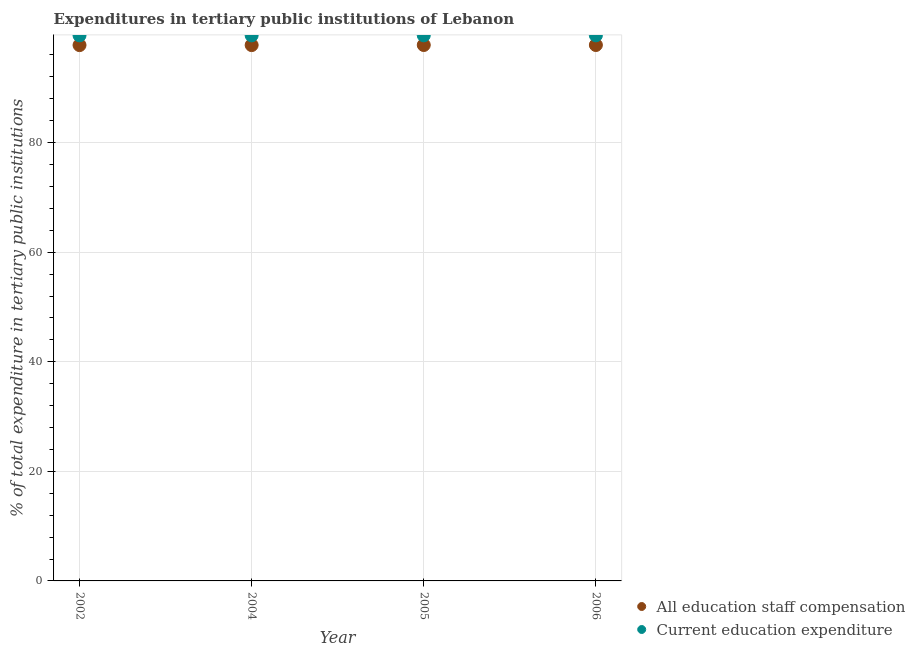Is the number of dotlines equal to the number of legend labels?
Provide a succinct answer. Yes. What is the expenditure in education in 2002?
Keep it short and to the point. 99.57. Across all years, what is the maximum expenditure in education?
Your response must be concise. 99.58. Across all years, what is the minimum expenditure in staff compensation?
Your response must be concise. 97.8. In which year was the expenditure in staff compensation minimum?
Ensure brevity in your answer.  2002. What is the total expenditure in staff compensation in the graph?
Provide a succinct answer. 391.22. What is the difference between the expenditure in staff compensation in 2002 and that in 2005?
Give a very brief answer. -0.02. What is the difference between the expenditure in education in 2002 and the expenditure in staff compensation in 2004?
Your answer should be compact. 1.78. What is the average expenditure in staff compensation per year?
Keep it short and to the point. 97.81. In the year 2006, what is the difference between the expenditure in education and expenditure in staff compensation?
Offer a terse response. 1.76. In how many years, is the expenditure in staff compensation greater than 64 %?
Give a very brief answer. 4. What is the ratio of the expenditure in staff compensation in 2004 to that in 2006?
Your answer should be very brief. 1. Is the expenditure in staff compensation in 2002 less than that in 2006?
Provide a short and direct response. Yes. Is the difference between the expenditure in staff compensation in 2002 and 2004 greater than the difference between the expenditure in education in 2002 and 2004?
Make the answer very short. Yes. What is the difference between the highest and the lowest expenditure in education?
Give a very brief answer. 0. Does the expenditure in education monotonically increase over the years?
Provide a short and direct response. No. How many dotlines are there?
Provide a succinct answer. 2. What is the difference between two consecutive major ticks on the Y-axis?
Provide a short and direct response. 20. How many legend labels are there?
Offer a terse response. 2. What is the title of the graph?
Make the answer very short. Expenditures in tertiary public institutions of Lebanon. Does "IMF concessional" appear as one of the legend labels in the graph?
Provide a short and direct response. No. What is the label or title of the Y-axis?
Offer a terse response. % of total expenditure in tertiary public institutions. What is the % of total expenditure in tertiary public institutions of All education staff compensation in 2002?
Give a very brief answer. 97.8. What is the % of total expenditure in tertiary public institutions of Current education expenditure in 2002?
Make the answer very short. 99.57. What is the % of total expenditure in tertiary public institutions in All education staff compensation in 2004?
Give a very brief answer. 97.8. What is the % of total expenditure in tertiary public institutions of Current education expenditure in 2004?
Keep it short and to the point. 99.57. What is the % of total expenditure in tertiary public institutions of All education staff compensation in 2005?
Give a very brief answer. 97.81. What is the % of total expenditure in tertiary public institutions in Current education expenditure in 2005?
Ensure brevity in your answer.  99.58. What is the % of total expenditure in tertiary public institutions of All education staff compensation in 2006?
Keep it short and to the point. 97.81. What is the % of total expenditure in tertiary public institutions in Current education expenditure in 2006?
Offer a terse response. 99.58. Across all years, what is the maximum % of total expenditure in tertiary public institutions of All education staff compensation?
Provide a succinct answer. 97.81. Across all years, what is the maximum % of total expenditure in tertiary public institutions in Current education expenditure?
Provide a short and direct response. 99.58. Across all years, what is the minimum % of total expenditure in tertiary public institutions of All education staff compensation?
Make the answer very short. 97.8. Across all years, what is the minimum % of total expenditure in tertiary public institutions of Current education expenditure?
Offer a very short reply. 99.57. What is the total % of total expenditure in tertiary public institutions in All education staff compensation in the graph?
Provide a short and direct response. 391.22. What is the total % of total expenditure in tertiary public institutions of Current education expenditure in the graph?
Keep it short and to the point. 398.3. What is the difference between the % of total expenditure in tertiary public institutions in All education staff compensation in 2002 and that in 2004?
Your response must be concise. -0. What is the difference between the % of total expenditure in tertiary public institutions of Current education expenditure in 2002 and that in 2004?
Make the answer very short. -0. What is the difference between the % of total expenditure in tertiary public institutions in All education staff compensation in 2002 and that in 2005?
Make the answer very short. -0.02. What is the difference between the % of total expenditure in tertiary public institutions of Current education expenditure in 2002 and that in 2005?
Your answer should be very brief. -0. What is the difference between the % of total expenditure in tertiary public institutions in All education staff compensation in 2002 and that in 2006?
Give a very brief answer. -0.02. What is the difference between the % of total expenditure in tertiary public institutions of Current education expenditure in 2002 and that in 2006?
Ensure brevity in your answer.  -0. What is the difference between the % of total expenditure in tertiary public institutions in All education staff compensation in 2004 and that in 2005?
Offer a terse response. -0.02. What is the difference between the % of total expenditure in tertiary public institutions in Current education expenditure in 2004 and that in 2005?
Make the answer very short. -0. What is the difference between the % of total expenditure in tertiary public institutions in All education staff compensation in 2004 and that in 2006?
Offer a very short reply. -0.02. What is the difference between the % of total expenditure in tertiary public institutions in Current education expenditure in 2004 and that in 2006?
Offer a terse response. -0. What is the difference between the % of total expenditure in tertiary public institutions in All education staff compensation in 2005 and that in 2006?
Your answer should be compact. 0. What is the difference between the % of total expenditure in tertiary public institutions in All education staff compensation in 2002 and the % of total expenditure in tertiary public institutions in Current education expenditure in 2004?
Keep it short and to the point. -1.78. What is the difference between the % of total expenditure in tertiary public institutions of All education staff compensation in 2002 and the % of total expenditure in tertiary public institutions of Current education expenditure in 2005?
Make the answer very short. -1.78. What is the difference between the % of total expenditure in tertiary public institutions in All education staff compensation in 2002 and the % of total expenditure in tertiary public institutions in Current education expenditure in 2006?
Offer a terse response. -1.78. What is the difference between the % of total expenditure in tertiary public institutions of All education staff compensation in 2004 and the % of total expenditure in tertiary public institutions of Current education expenditure in 2005?
Offer a terse response. -1.78. What is the difference between the % of total expenditure in tertiary public institutions of All education staff compensation in 2004 and the % of total expenditure in tertiary public institutions of Current education expenditure in 2006?
Your response must be concise. -1.78. What is the difference between the % of total expenditure in tertiary public institutions of All education staff compensation in 2005 and the % of total expenditure in tertiary public institutions of Current education expenditure in 2006?
Make the answer very short. -1.76. What is the average % of total expenditure in tertiary public institutions of All education staff compensation per year?
Give a very brief answer. 97.81. What is the average % of total expenditure in tertiary public institutions in Current education expenditure per year?
Give a very brief answer. 99.57. In the year 2002, what is the difference between the % of total expenditure in tertiary public institutions in All education staff compensation and % of total expenditure in tertiary public institutions in Current education expenditure?
Your answer should be very brief. -1.78. In the year 2004, what is the difference between the % of total expenditure in tertiary public institutions in All education staff compensation and % of total expenditure in tertiary public institutions in Current education expenditure?
Keep it short and to the point. -1.78. In the year 2005, what is the difference between the % of total expenditure in tertiary public institutions of All education staff compensation and % of total expenditure in tertiary public institutions of Current education expenditure?
Offer a terse response. -1.76. In the year 2006, what is the difference between the % of total expenditure in tertiary public institutions of All education staff compensation and % of total expenditure in tertiary public institutions of Current education expenditure?
Offer a very short reply. -1.76. What is the ratio of the % of total expenditure in tertiary public institutions in All education staff compensation in 2002 to that in 2004?
Your answer should be compact. 1. What is the ratio of the % of total expenditure in tertiary public institutions in Current education expenditure in 2002 to that in 2004?
Offer a very short reply. 1. What is the ratio of the % of total expenditure in tertiary public institutions in All education staff compensation in 2002 to that in 2005?
Offer a terse response. 1. What is the ratio of the % of total expenditure in tertiary public institutions of Current education expenditure in 2002 to that in 2005?
Your answer should be very brief. 1. What is the ratio of the % of total expenditure in tertiary public institutions of Current education expenditure in 2002 to that in 2006?
Make the answer very short. 1. What is the ratio of the % of total expenditure in tertiary public institutions of Current education expenditure in 2004 to that in 2005?
Give a very brief answer. 1. What is the ratio of the % of total expenditure in tertiary public institutions of All education staff compensation in 2005 to that in 2006?
Make the answer very short. 1. What is the difference between the highest and the second highest % of total expenditure in tertiary public institutions of All education staff compensation?
Provide a succinct answer. 0. What is the difference between the highest and the lowest % of total expenditure in tertiary public institutions in All education staff compensation?
Your answer should be very brief. 0.02. What is the difference between the highest and the lowest % of total expenditure in tertiary public institutions in Current education expenditure?
Provide a short and direct response. 0. 